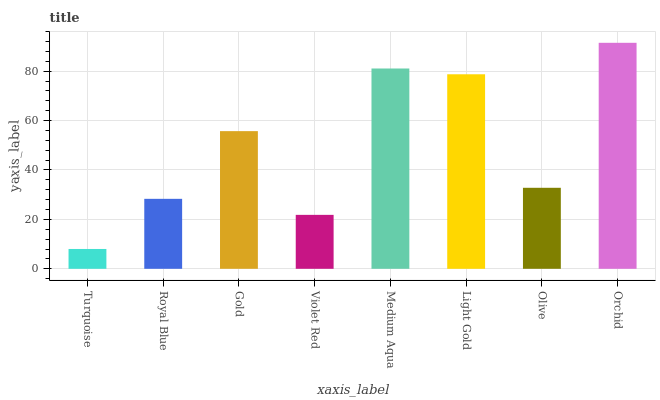Is Royal Blue the minimum?
Answer yes or no. No. Is Royal Blue the maximum?
Answer yes or no. No. Is Royal Blue greater than Turquoise?
Answer yes or no. Yes. Is Turquoise less than Royal Blue?
Answer yes or no. Yes. Is Turquoise greater than Royal Blue?
Answer yes or no. No. Is Royal Blue less than Turquoise?
Answer yes or no. No. Is Gold the high median?
Answer yes or no. Yes. Is Olive the low median?
Answer yes or no. Yes. Is Royal Blue the high median?
Answer yes or no. No. Is Violet Red the low median?
Answer yes or no. No. 